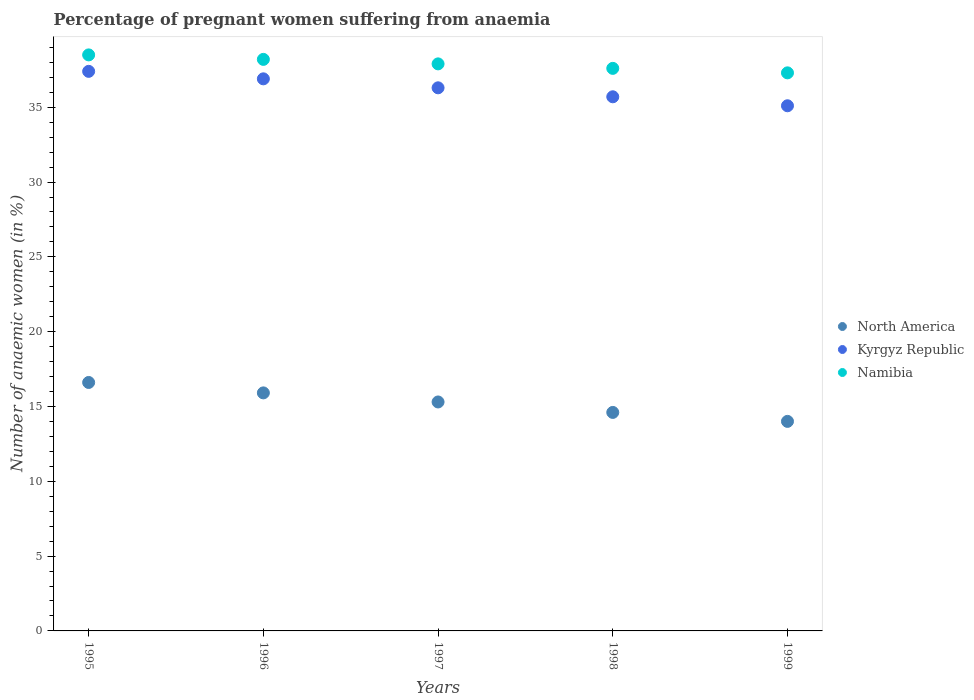What is the number of anaemic women in North America in 1999?
Your answer should be compact. 14.01. Across all years, what is the maximum number of anaemic women in Namibia?
Keep it short and to the point. 38.5. Across all years, what is the minimum number of anaemic women in Namibia?
Your answer should be compact. 37.3. In which year was the number of anaemic women in North America maximum?
Provide a succinct answer. 1995. What is the total number of anaemic women in Kyrgyz Republic in the graph?
Ensure brevity in your answer.  181.4. What is the difference between the number of anaemic women in Kyrgyz Republic in 1995 and that in 1999?
Provide a succinct answer. 2.3. What is the difference between the number of anaemic women in North America in 1997 and the number of anaemic women in Namibia in 1999?
Your answer should be compact. -22. What is the average number of anaemic women in Kyrgyz Republic per year?
Make the answer very short. 36.28. In the year 1995, what is the difference between the number of anaemic women in North America and number of anaemic women in Kyrgyz Republic?
Give a very brief answer. -20.79. What is the ratio of the number of anaemic women in North America in 1995 to that in 1999?
Ensure brevity in your answer.  1.19. Is the number of anaemic women in Kyrgyz Republic in 1995 less than that in 1998?
Your response must be concise. No. What is the difference between the highest and the second highest number of anaemic women in Kyrgyz Republic?
Provide a succinct answer. 0.5. What is the difference between the highest and the lowest number of anaemic women in Namibia?
Your answer should be very brief. 1.2. Is the sum of the number of anaemic women in North America in 1998 and 1999 greater than the maximum number of anaemic women in Kyrgyz Republic across all years?
Offer a terse response. No. Is the number of anaemic women in North America strictly greater than the number of anaemic women in Namibia over the years?
Provide a succinct answer. No. How many years are there in the graph?
Give a very brief answer. 5. What is the difference between two consecutive major ticks on the Y-axis?
Give a very brief answer. 5. Are the values on the major ticks of Y-axis written in scientific E-notation?
Your answer should be very brief. No. Does the graph contain grids?
Provide a succinct answer. No. Where does the legend appear in the graph?
Ensure brevity in your answer.  Center right. How many legend labels are there?
Your answer should be compact. 3. How are the legend labels stacked?
Give a very brief answer. Vertical. What is the title of the graph?
Offer a terse response. Percentage of pregnant women suffering from anaemia. Does "West Bank and Gaza" appear as one of the legend labels in the graph?
Your answer should be compact. No. What is the label or title of the Y-axis?
Offer a terse response. Number of anaemic women (in %). What is the Number of anaemic women (in %) of North America in 1995?
Give a very brief answer. 16.61. What is the Number of anaemic women (in %) of Kyrgyz Republic in 1995?
Keep it short and to the point. 37.4. What is the Number of anaemic women (in %) of Namibia in 1995?
Make the answer very short. 38.5. What is the Number of anaemic women (in %) of North America in 1996?
Ensure brevity in your answer.  15.91. What is the Number of anaemic women (in %) in Kyrgyz Republic in 1996?
Your answer should be very brief. 36.9. What is the Number of anaemic women (in %) in Namibia in 1996?
Ensure brevity in your answer.  38.2. What is the Number of anaemic women (in %) of North America in 1997?
Your answer should be very brief. 15.3. What is the Number of anaemic women (in %) of Kyrgyz Republic in 1997?
Your response must be concise. 36.3. What is the Number of anaemic women (in %) in Namibia in 1997?
Offer a terse response. 37.9. What is the Number of anaemic women (in %) of North America in 1998?
Provide a short and direct response. 14.6. What is the Number of anaemic women (in %) of Kyrgyz Republic in 1998?
Your response must be concise. 35.7. What is the Number of anaemic women (in %) of Namibia in 1998?
Your answer should be compact. 37.6. What is the Number of anaemic women (in %) in North America in 1999?
Your response must be concise. 14.01. What is the Number of anaemic women (in %) in Kyrgyz Republic in 1999?
Provide a short and direct response. 35.1. What is the Number of anaemic women (in %) of Namibia in 1999?
Keep it short and to the point. 37.3. Across all years, what is the maximum Number of anaemic women (in %) in North America?
Your answer should be compact. 16.61. Across all years, what is the maximum Number of anaemic women (in %) of Kyrgyz Republic?
Keep it short and to the point. 37.4. Across all years, what is the maximum Number of anaemic women (in %) of Namibia?
Give a very brief answer. 38.5. Across all years, what is the minimum Number of anaemic women (in %) of North America?
Your answer should be very brief. 14.01. Across all years, what is the minimum Number of anaemic women (in %) of Kyrgyz Republic?
Provide a short and direct response. 35.1. Across all years, what is the minimum Number of anaemic women (in %) of Namibia?
Your answer should be compact. 37.3. What is the total Number of anaemic women (in %) in North America in the graph?
Your answer should be compact. 76.43. What is the total Number of anaemic women (in %) in Kyrgyz Republic in the graph?
Your answer should be very brief. 181.4. What is the total Number of anaemic women (in %) of Namibia in the graph?
Provide a succinct answer. 189.5. What is the difference between the Number of anaemic women (in %) in North America in 1995 and that in 1996?
Provide a succinct answer. 0.7. What is the difference between the Number of anaemic women (in %) of North America in 1995 and that in 1997?
Provide a short and direct response. 1.3. What is the difference between the Number of anaemic women (in %) of Kyrgyz Republic in 1995 and that in 1997?
Your response must be concise. 1.1. What is the difference between the Number of anaemic women (in %) in North America in 1995 and that in 1998?
Make the answer very short. 2. What is the difference between the Number of anaemic women (in %) in Namibia in 1995 and that in 1998?
Keep it short and to the point. 0.9. What is the difference between the Number of anaemic women (in %) in North America in 1995 and that in 1999?
Your response must be concise. 2.6. What is the difference between the Number of anaemic women (in %) in Kyrgyz Republic in 1995 and that in 1999?
Your answer should be very brief. 2.3. What is the difference between the Number of anaemic women (in %) of Namibia in 1995 and that in 1999?
Offer a very short reply. 1.2. What is the difference between the Number of anaemic women (in %) in North America in 1996 and that in 1997?
Give a very brief answer. 0.61. What is the difference between the Number of anaemic women (in %) of North America in 1996 and that in 1998?
Your answer should be very brief. 1.31. What is the difference between the Number of anaemic women (in %) of Kyrgyz Republic in 1996 and that in 1998?
Provide a short and direct response. 1.2. What is the difference between the Number of anaemic women (in %) of Namibia in 1996 and that in 1998?
Provide a short and direct response. 0.6. What is the difference between the Number of anaemic women (in %) in North America in 1996 and that in 1999?
Keep it short and to the point. 1.9. What is the difference between the Number of anaemic women (in %) of Kyrgyz Republic in 1996 and that in 1999?
Provide a succinct answer. 1.8. What is the difference between the Number of anaemic women (in %) in Namibia in 1996 and that in 1999?
Give a very brief answer. 0.9. What is the difference between the Number of anaemic women (in %) in North America in 1997 and that in 1998?
Give a very brief answer. 0.7. What is the difference between the Number of anaemic women (in %) in Kyrgyz Republic in 1997 and that in 1998?
Keep it short and to the point. 0.6. What is the difference between the Number of anaemic women (in %) of North America in 1997 and that in 1999?
Give a very brief answer. 1.3. What is the difference between the Number of anaemic women (in %) in Kyrgyz Republic in 1997 and that in 1999?
Your answer should be very brief. 1.2. What is the difference between the Number of anaemic women (in %) in Namibia in 1997 and that in 1999?
Make the answer very short. 0.6. What is the difference between the Number of anaemic women (in %) of North America in 1998 and that in 1999?
Your answer should be very brief. 0.6. What is the difference between the Number of anaemic women (in %) of Kyrgyz Republic in 1998 and that in 1999?
Make the answer very short. 0.6. What is the difference between the Number of anaemic women (in %) in Namibia in 1998 and that in 1999?
Give a very brief answer. 0.3. What is the difference between the Number of anaemic women (in %) of North America in 1995 and the Number of anaemic women (in %) of Kyrgyz Republic in 1996?
Offer a very short reply. -20.29. What is the difference between the Number of anaemic women (in %) of North America in 1995 and the Number of anaemic women (in %) of Namibia in 1996?
Your answer should be very brief. -21.59. What is the difference between the Number of anaemic women (in %) of Kyrgyz Republic in 1995 and the Number of anaemic women (in %) of Namibia in 1996?
Offer a terse response. -0.8. What is the difference between the Number of anaemic women (in %) of North America in 1995 and the Number of anaemic women (in %) of Kyrgyz Republic in 1997?
Give a very brief answer. -19.69. What is the difference between the Number of anaemic women (in %) in North America in 1995 and the Number of anaemic women (in %) in Namibia in 1997?
Give a very brief answer. -21.29. What is the difference between the Number of anaemic women (in %) in Kyrgyz Republic in 1995 and the Number of anaemic women (in %) in Namibia in 1997?
Offer a terse response. -0.5. What is the difference between the Number of anaemic women (in %) in North America in 1995 and the Number of anaemic women (in %) in Kyrgyz Republic in 1998?
Your response must be concise. -19.09. What is the difference between the Number of anaemic women (in %) of North America in 1995 and the Number of anaemic women (in %) of Namibia in 1998?
Give a very brief answer. -20.99. What is the difference between the Number of anaemic women (in %) of North America in 1995 and the Number of anaemic women (in %) of Kyrgyz Republic in 1999?
Keep it short and to the point. -18.49. What is the difference between the Number of anaemic women (in %) of North America in 1995 and the Number of anaemic women (in %) of Namibia in 1999?
Provide a short and direct response. -20.69. What is the difference between the Number of anaemic women (in %) of North America in 1996 and the Number of anaemic women (in %) of Kyrgyz Republic in 1997?
Give a very brief answer. -20.39. What is the difference between the Number of anaemic women (in %) of North America in 1996 and the Number of anaemic women (in %) of Namibia in 1997?
Keep it short and to the point. -21.99. What is the difference between the Number of anaemic women (in %) in Kyrgyz Republic in 1996 and the Number of anaemic women (in %) in Namibia in 1997?
Give a very brief answer. -1. What is the difference between the Number of anaemic women (in %) of North America in 1996 and the Number of anaemic women (in %) of Kyrgyz Republic in 1998?
Provide a short and direct response. -19.79. What is the difference between the Number of anaemic women (in %) in North America in 1996 and the Number of anaemic women (in %) in Namibia in 1998?
Offer a very short reply. -21.69. What is the difference between the Number of anaemic women (in %) in North America in 1996 and the Number of anaemic women (in %) in Kyrgyz Republic in 1999?
Ensure brevity in your answer.  -19.19. What is the difference between the Number of anaemic women (in %) of North America in 1996 and the Number of anaemic women (in %) of Namibia in 1999?
Offer a very short reply. -21.39. What is the difference between the Number of anaemic women (in %) of North America in 1997 and the Number of anaemic women (in %) of Kyrgyz Republic in 1998?
Make the answer very short. -20.4. What is the difference between the Number of anaemic women (in %) of North America in 1997 and the Number of anaemic women (in %) of Namibia in 1998?
Make the answer very short. -22.3. What is the difference between the Number of anaemic women (in %) in North America in 1997 and the Number of anaemic women (in %) in Kyrgyz Republic in 1999?
Provide a succinct answer. -19.8. What is the difference between the Number of anaemic women (in %) in North America in 1997 and the Number of anaemic women (in %) in Namibia in 1999?
Your answer should be very brief. -22. What is the difference between the Number of anaemic women (in %) in North America in 1998 and the Number of anaemic women (in %) in Kyrgyz Republic in 1999?
Make the answer very short. -20.5. What is the difference between the Number of anaemic women (in %) of North America in 1998 and the Number of anaemic women (in %) of Namibia in 1999?
Give a very brief answer. -22.7. What is the difference between the Number of anaemic women (in %) of Kyrgyz Republic in 1998 and the Number of anaemic women (in %) of Namibia in 1999?
Give a very brief answer. -1.6. What is the average Number of anaemic women (in %) in North America per year?
Provide a succinct answer. 15.29. What is the average Number of anaemic women (in %) in Kyrgyz Republic per year?
Offer a terse response. 36.28. What is the average Number of anaemic women (in %) in Namibia per year?
Offer a very short reply. 37.9. In the year 1995, what is the difference between the Number of anaemic women (in %) in North America and Number of anaemic women (in %) in Kyrgyz Republic?
Your answer should be compact. -20.79. In the year 1995, what is the difference between the Number of anaemic women (in %) in North America and Number of anaemic women (in %) in Namibia?
Provide a short and direct response. -21.89. In the year 1995, what is the difference between the Number of anaemic women (in %) of Kyrgyz Republic and Number of anaemic women (in %) of Namibia?
Give a very brief answer. -1.1. In the year 1996, what is the difference between the Number of anaemic women (in %) in North America and Number of anaemic women (in %) in Kyrgyz Republic?
Your answer should be very brief. -20.99. In the year 1996, what is the difference between the Number of anaemic women (in %) in North America and Number of anaemic women (in %) in Namibia?
Offer a terse response. -22.29. In the year 1997, what is the difference between the Number of anaemic women (in %) of North America and Number of anaemic women (in %) of Kyrgyz Republic?
Give a very brief answer. -21. In the year 1997, what is the difference between the Number of anaemic women (in %) in North America and Number of anaemic women (in %) in Namibia?
Provide a succinct answer. -22.6. In the year 1998, what is the difference between the Number of anaemic women (in %) of North America and Number of anaemic women (in %) of Kyrgyz Republic?
Ensure brevity in your answer.  -21.1. In the year 1998, what is the difference between the Number of anaemic women (in %) in North America and Number of anaemic women (in %) in Namibia?
Provide a short and direct response. -23. In the year 1998, what is the difference between the Number of anaemic women (in %) of Kyrgyz Republic and Number of anaemic women (in %) of Namibia?
Give a very brief answer. -1.9. In the year 1999, what is the difference between the Number of anaemic women (in %) of North America and Number of anaemic women (in %) of Kyrgyz Republic?
Make the answer very short. -21.09. In the year 1999, what is the difference between the Number of anaemic women (in %) of North America and Number of anaemic women (in %) of Namibia?
Make the answer very short. -23.29. In the year 1999, what is the difference between the Number of anaemic women (in %) in Kyrgyz Republic and Number of anaemic women (in %) in Namibia?
Provide a short and direct response. -2.2. What is the ratio of the Number of anaemic women (in %) of North America in 1995 to that in 1996?
Provide a succinct answer. 1.04. What is the ratio of the Number of anaemic women (in %) in Kyrgyz Republic in 1995 to that in 1996?
Your response must be concise. 1.01. What is the ratio of the Number of anaemic women (in %) in Namibia in 1995 to that in 1996?
Your answer should be very brief. 1.01. What is the ratio of the Number of anaemic women (in %) in North America in 1995 to that in 1997?
Give a very brief answer. 1.09. What is the ratio of the Number of anaemic women (in %) in Kyrgyz Republic in 1995 to that in 1997?
Your answer should be compact. 1.03. What is the ratio of the Number of anaemic women (in %) of Namibia in 1995 to that in 1997?
Offer a very short reply. 1.02. What is the ratio of the Number of anaemic women (in %) of North America in 1995 to that in 1998?
Offer a very short reply. 1.14. What is the ratio of the Number of anaemic women (in %) of Kyrgyz Republic in 1995 to that in 1998?
Ensure brevity in your answer.  1.05. What is the ratio of the Number of anaemic women (in %) of Namibia in 1995 to that in 1998?
Keep it short and to the point. 1.02. What is the ratio of the Number of anaemic women (in %) of North America in 1995 to that in 1999?
Ensure brevity in your answer.  1.19. What is the ratio of the Number of anaemic women (in %) of Kyrgyz Republic in 1995 to that in 1999?
Provide a short and direct response. 1.07. What is the ratio of the Number of anaemic women (in %) of Namibia in 1995 to that in 1999?
Keep it short and to the point. 1.03. What is the ratio of the Number of anaemic women (in %) in North America in 1996 to that in 1997?
Ensure brevity in your answer.  1.04. What is the ratio of the Number of anaemic women (in %) of Kyrgyz Republic in 1996 to that in 1997?
Give a very brief answer. 1.02. What is the ratio of the Number of anaemic women (in %) of Namibia in 1996 to that in 1997?
Your response must be concise. 1.01. What is the ratio of the Number of anaemic women (in %) of North America in 1996 to that in 1998?
Ensure brevity in your answer.  1.09. What is the ratio of the Number of anaemic women (in %) of Kyrgyz Republic in 1996 to that in 1998?
Provide a succinct answer. 1.03. What is the ratio of the Number of anaemic women (in %) in Namibia in 1996 to that in 1998?
Provide a succinct answer. 1.02. What is the ratio of the Number of anaemic women (in %) of North America in 1996 to that in 1999?
Provide a short and direct response. 1.14. What is the ratio of the Number of anaemic women (in %) in Kyrgyz Republic in 1996 to that in 1999?
Give a very brief answer. 1.05. What is the ratio of the Number of anaemic women (in %) of Namibia in 1996 to that in 1999?
Offer a terse response. 1.02. What is the ratio of the Number of anaemic women (in %) in North America in 1997 to that in 1998?
Your response must be concise. 1.05. What is the ratio of the Number of anaemic women (in %) of Kyrgyz Republic in 1997 to that in 1998?
Make the answer very short. 1.02. What is the ratio of the Number of anaemic women (in %) of North America in 1997 to that in 1999?
Make the answer very short. 1.09. What is the ratio of the Number of anaemic women (in %) of Kyrgyz Republic in 1997 to that in 1999?
Offer a terse response. 1.03. What is the ratio of the Number of anaemic women (in %) in Namibia in 1997 to that in 1999?
Offer a very short reply. 1.02. What is the ratio of the Number of anaemic women (in %) of North America in 1998 to that in 1999?
Ensure brevity in your answer.  1.04. What is the ratio of the Number of anaemic women (in %) in Kyrgyz Republic in 1998 to that in 1999?
Ensure brevity in your answer.  1.02. What is the difference between the highest and the second highest Number of anaemic women (in %) in North America?
Your response must be concise. 0.7. What is the difference between the highest and the lowest Number of anaemic women (in %) of North America?
Offer a very short reply. 2.6. What is the difference between the highest and the lowest Number of anaemic women (in %) of Kyrgyz Republic?
Provide a short and direct response. 2.3. 